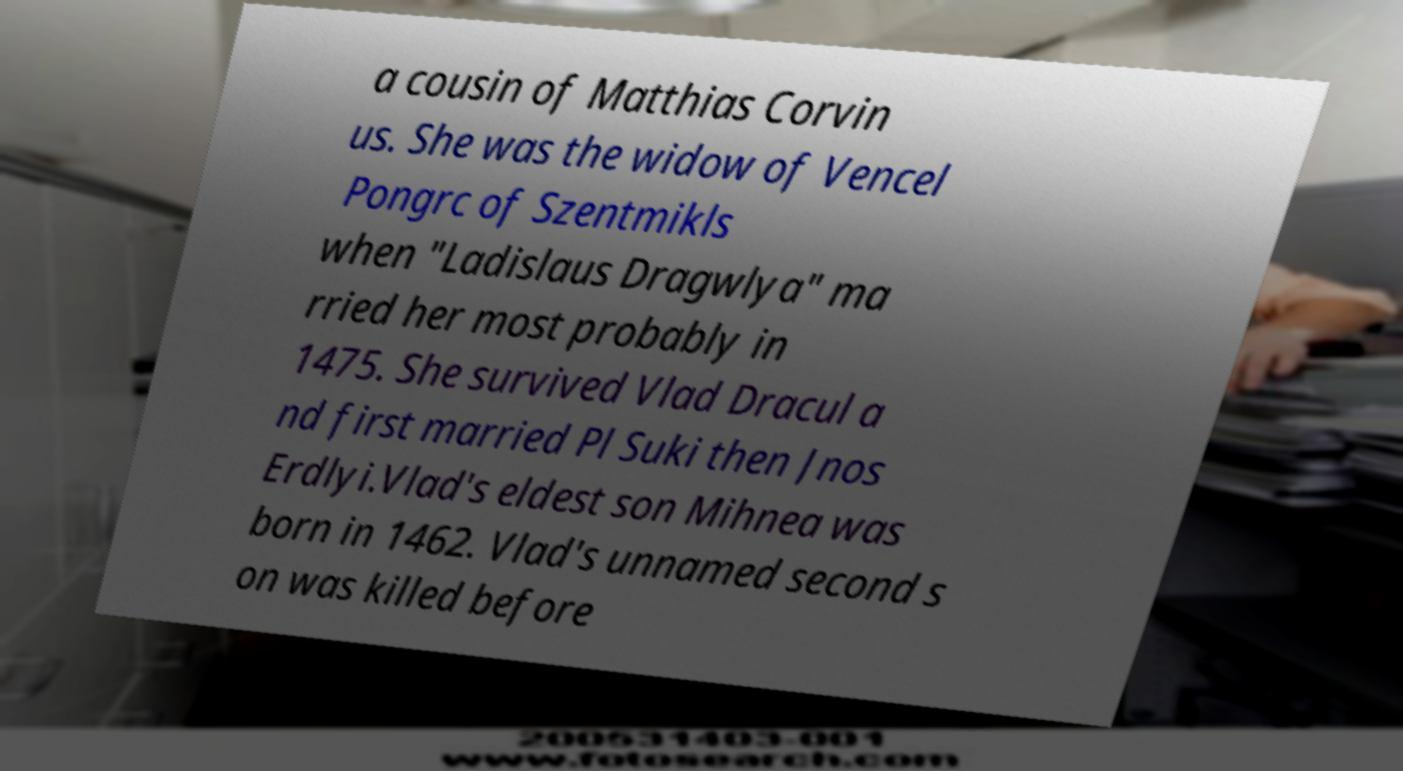Please identify and transcribe the text found in this image. a cousin of Matthias Corvin us. She was the widow of Vencel Pongrc of Szentmikls when "Ladislaus Dragwlya" ma rried her most probably in 1475. She survived Vlad Dracul a nd first married Pl Suki then Jnos Erdlyi.Vlad's eldest son Mihnea was born in 1462. Vlad's unnamed second s on was killed before 